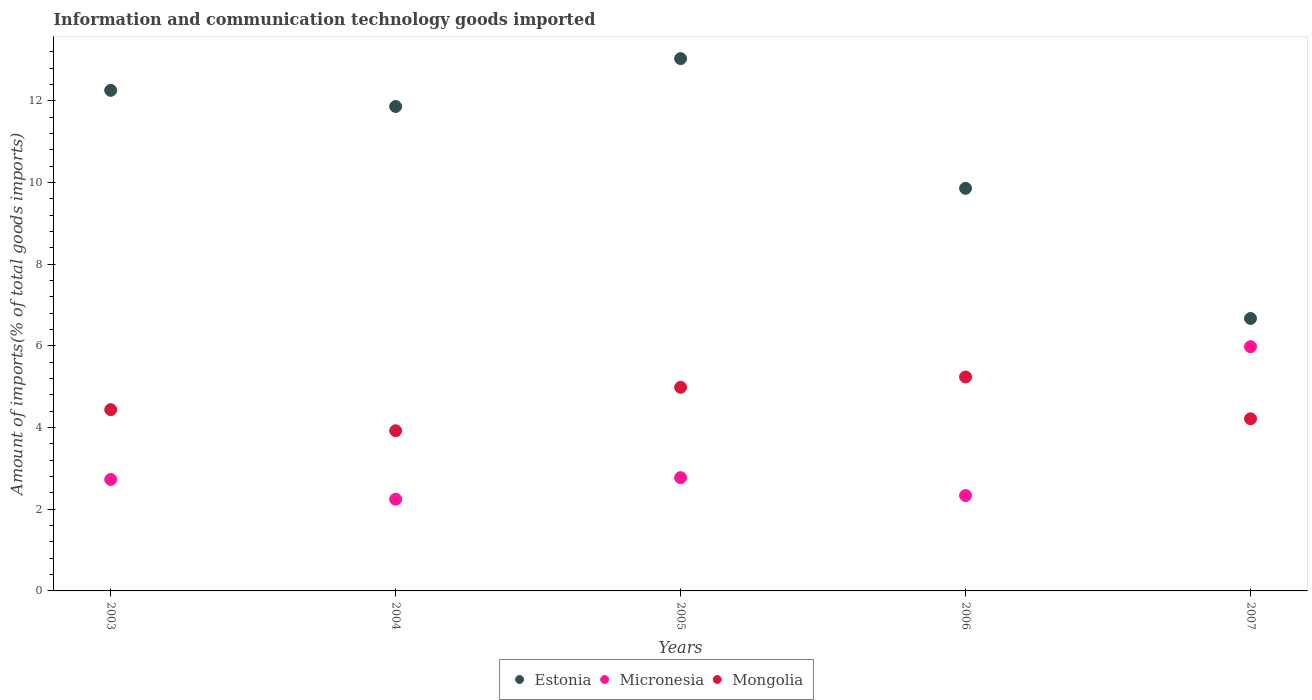Is the number of dotlines equal to the number of legend labels?
Give a very brief answer. Yes. What is the amount of goods imported in Mongolia in 2007?
Keep it short and to the point. 4.22. Across all years, what is the maximum amount of goods imported in Mongolia?
Ensure brevity in your answer.  5.24. Across all years, what is the minimum amount of goods imported in Estonia?
Your answer should be compact. 6.67. In which year was the amount of goods imported in Mongolia maximum?
Ensure brevity in your answer.  2006. What is the total amount of goods imported in Mongolia in the graph?
Ensure brevity in your answer.  22.8. What is the difference between the amount of goods imported in Mongolia in 2004 and that in 2005?
Provide a succinct answer. -1.06. What is the difference between the amount of goods imported in Mongolia in 2006 and the amount of goods imported in Estonia in 2007?
Offer a very short reply. -1.43. What is the average amount of goods imported in Estonia per year?
Make the answer very short. 10.74. In the year 2007, what is the difference between the amount of goods imported in Estonia and amount of goods imported in Micronesia?
Your answer should be compact. 0.69. What is the ratio of the amount of goods imported in Micronesia in 2003 to that in 2007?
Ensure brevity in your answer.  0.46. Is the amount of goods imported in Estonia in 2005 less than that in 2007?
Make the answer very short. No. What is the difference between the highest and the second highest amount of goods imported in Estonia?
Make the answer very short. 0.78. What is the difference between the highest and the lowest amount of goods imported in Micronesia?
Give a very brief answer. 3.73. In how many years, is the amount of goods imported in Mongolia greater than the average amount of goods imported in Mongolia taken over all years?
Give a very brief answer. 2. Is the sum of the amount of goods imported in Estonia in 2003 and 2006 greater than the maximum amount of goods imported in Mongolia across all years?
Give a very brief answer. Yes. What is the difference between two consecutive major ticks on the Y-axis?
Your response must be concise. 2. Does the graph contain grids?
Keep it short and to the point. No. Where does the legend appear in the graph?
Your response must be concise. Bottom center. How are the legend labels stacked?
Keep it short and to the point. Horizontal. What is the title of the graph?
Keep it short and to the point. Information and communication technology goods imported. What is the label or title of the Y-axis?
Provide a succinct answer. Amount of imports(% of total goods imports). What is the Amount of imports(% of total goods imports) in Estonia in 2003?
Your response must be concise. 12.26. What is the Amount of imports(% of total goods imports) of Micronesia in 2003?
Provide a short and direct response. 2.73. What is the Amount of imports(% of total goods imports) of Mongolia in 2003?
Your answer should be very brief. 4.44. What is the Amount of imports(% of total goods imports) of Estonia in 2004?
Offer a very short reply. 11.86. What is the Amount of imports(% of total goods imports) of Micronesia in 2004?
Your response must be concise. 2.25. What is the Amount of imports(% of total goods imports) of Mongolia in 2004?
Offer a very short reply. 3.92. What is the Amount of imports(% of total goods imports) in Estonia in 2005?
Your answer should be compact. 13.04. What is the Amount of imports(% of total goods imports) in Micronesia in 2005?
Offer a terse response. 2.77. What is the Amount of imports(% of total goods imports) in Mongolia in 2005?
Provide a succinct answer. 4.99. What is the Amount of imports(% of total goods imports) of Estonia in 2006?
Keep it short and to the point. 9.86. What is the Amount of imports(% of total goods imports) in Micronesia in 2006?
Your response must be concise. 2.34. What is the Amount of imports(% of total goods imports) in Mongolia in 2006?
Provide a short and direct response. 5.24. What is the Amount of imports(% of total goods imports) in Estonia in 2007?
Provide a short and direct response. 6.67. What is the Amount of imports(% of total goods imports) of Micronesia in 2007?
Your answer should be compact. 5.98. What is the Amount of imports(% of total goods imports) in Mongolia in 2007?
Ensure brevity in your answer.  4.22. Across all years, what is the maximum Amount of imports(% of total goods imports) of Estonia?
Your answer should be compact. 13.04. Across all years, what is the maximum Amount of imports(% of total goods imports) in Micronesia?
Keep it short and to the point. 5.98. Across all years, what is the maximum Amount of imports(% of total goods imports) of Mongolia?
Your answer should be very brief. 5.24. Across all years, what is the minimum Amount of imports(% of total goods imports) of Estonia?
Offer a terse response. 6.67. Across all years, what is the minimum Amount of imports(% of total goods imports) of Micronesia?
Your answer should be very brief. 2.25. Across all years, what is the minimum Amount of imports(% of total goods imports) of Mongolia?
Provide a short and direct response. 3.92. What is the total Amount of imports(% of total goods imports) in Estonia in the graph?
Your answer should be compact. 53.69. What is the total Amount of imports(% of total goods imports) of Micronesia in the graph?
Your answer should be very brief. 16.06. What is the total Amount of imports(% of total goods imports) of Mongolia in the graph?
Offer a very short reply. 22.8. What is the difference between the Amount of imports(% of total goods imports) of Estonia in 2003 and that in 2004?
Provide a short and direct response. 0.4. What is the difference between the Amount of imports(% of total goods imports) of Micronesia in 2003 and that in 2004?
Your response must be concise. 0.48. What is the difference between the Amount of imports(% of total goods imports) of Mongolia in 2003 and that in 2004?
Provide a succinct answer. 0.52. What is the difference between the Amount of imports(% of total goods imports) of Estonia in 2003 and that in 2005?
Your answer should be compact. -0.78. What is the difference between the Amount of imports(% of total goods imports) of Micronesia in 2003 and that in 2005?
Your response must be concise. -0.04. What is the difference between the Amount of imports(% of total goods imports) of Mongolia in 2003 and that in 2005?
Your answer should be very brief. -0.55. What is the difference between the Amount of imports(% of total goods imports) of Estonia in 2003 and that in 2006?
Provide a short and direct response. 2.4. What is the difference between the Amount of imports(% of total goods imports) in Micronesia in 2003 and that in 2006?
Offer a very short reply. 0.39. What is the difference between the Amount of imports(% of total goods imports) of Mongolia in 2003 and that in 2006?
Offer a terse response. -0.8. What is the difference between the Amount of imports(% of total goods imports) in Estonia in 2003 and that in 2007?
Keep it short and to the point. 5.59. What is the difference between the Amount of imports(% of total goods imports) of Micronesia in 2003 and that in 2007?
Your answer should be compact. -3.25. What is the difference between the Amount of imports(% of total goods imports) of Mongolia in 2003 and that in 2007?
Make the answer very short. 0.22. What is the difference between the Amount of imports(% of total goods imports) of Estonia in 2004 and that in 2005?
Provide a short and direct response. -1.17. What is the difference between the Amount of imports(% of total goods imports) in Micronesia in 2004 and that in 2005?
Provide a succinct answer. -0.53. What is the difference between the Amount of imports(% of total goods imports) in Mongolia in 2004 and that in 2005?
Offer a terse response. -1.06. What is the difference between the Amount of imports(% of total goods imports) in Estonia in 2004 and that in 2006?
Make the answer very short. 2. What is the difference between the Amount of imports(% of total goods imports) in Micronesia in 2004 and that in 2006?
Your answer should be compact. -0.09. What is the difference between the Amount of imports(% of total goods imports) in Mongolia in 2004 and that in 2006?
Keep it short and to the point. -1.32. What is the difference between the Amount of imports(% of total goods imports) of Estonia in 2004 and that in 2007?
Give a very brief answer. 5.19. What is the difference between the Amount of imports(% of total goods imports) in Micronesia in 2004 and that in 2007?
Offer a terse response. -3.73. What is the difference between the Amount of imports(% of total goods imports) of Mongolia in 2004 and that in 2007?
Ensure brevity in your answer.  -0.29. What is the difference between the Amount of imports(% of total goods imports) of Estonia in 2005 and that in 2006?
Keep it short and to the point. 3.18. What is the difference between the Amount of imports(% of total goods imports) of Micronesia in 2005 and that in 2006?
Your answer should be compact. 0.44. What is the difference between the Amount of imports(% of total goods imports) in Mongolia in 2005 and that in 2006?
Give a very brief answer. -0.25. What is the difference between the Amount of imports(% of total goods imports) of Estonia in 2005 and that in 2007?
Keep it short and to the point. 6.36. What is the difference between the Amount of imports(% of total goods imports) of Micronesia in 2005 and that in 2007?
Your response must be concise. -3.21. What is the difference between the Amount of imports(% of total goods imports) in Mongolia in 2005 and that in 2007?
Give a very brief answer. 0.77. What is the difference between the Amount of imports(% of total goods imports) of Estonia in 2006 and that in 2007?
Your response must be concise. 3.19. What is the difference between the Amount of imports(% of total goods imports) in Micronesia in 2006 and that in 2007?
Ensure brevity in your answer.  -3.65. What is the difference between the Amount of imports(% of total goods imports) of Mongolia in 2006 and that in 2007?
Offer a very short reply. 1.02. What is the difference between the Amount of imports(% of total goods imports) of Estonia in 2003 and the Amount of imports(% of total goods imports) of Micronesia in 2004?
Your answer should be very brief. 10.01. What is the difference between the Amount of imports(% of total goods imports) in Estonia in 2003 and the Amount of imports(% of total goods imports) in Mongolia in 2004?
Ensure brevity in your answer.  8.34. What is the difference between the Amount of imports(% of total goods imports) of Micronesia in 2003 and the Amount of imports(% of total goods imports) of Mongolia in 2004?
Give a very brief answer. -1.19. What is the difference between the Amount of imports(% of total goods imports) in Estonia in 2003 and the Amount of imports(% of total goods imports) in Micronesia in 2005?
Your answer should be very brief. 9.49. What is the difference between the Amount of imports(% of total goods imports) of Estonia in 2003 and the Amount of imports(% of total goods imports) of Mongolia in 2005?
Provide a succinct answer. 7.27. What is the difference between the Amount of imports(% of total goods imports) in Micronesia in 2003 and the Amount of imports(% of total goods imports) in Mongolia in 2005?
Make the answer very short. -2.26. What is the difference between the Amount of imports(% of total goods imports) in Estonia in 2003 and the Amount of imports(% of total goods imports) in Micronesia in 2006?
Make the answer very short. 9.92. What is the difference between the Amount of imports(% of total goods imports) of Estonia in 2003 and the Amount of imports(% of total goods imports) of Mongolia in 2006?
Your response must be concise. 7.02. What is the difference between the Amount of imports(% of total goods imports) in Micronesia in 2003 and the Amount of imports(% of total goods imports) in Mongolia in 2006?
Your response must be concise. -2.51. What is the difference between the Amount of imports(% of total goods imports) of Estonia in 2003 and the Amount of imports(% of total goods imports) of Micronesia in 2007?
Your answer should be compact. 6.28. What is the difference between the Amount of imports(% of total goods imports) of Estonia in 2003 and the Amount of imports(% of total goods imports) of Mongolia in 2007?
Keep it short and to the point. 8.04. What is the difference between the Amount of imports(% of total goods imports) in Micronesia in 2003 and the Amount of imports(% of total goods imports) in Mongolia in 2007?
Your answer should be very brief. -1.49. What is the difference between the Amount of imports(% of total goods imports) of Estonia in 2004 and the Amount of imports(% of total goods imports) of Micronesia in 2005?
Your response must be concise. 9.09. What is the difference between the Amount of imports(% of total goods imports) in Estonia in 2004 and the Amount of imports(% of total goods imports) in Mongolia in 2005?
Your answer should be very brief. 6.88. What is the difference between the Amount of imports(% of total goods imports) of Micronesia in 2004 and the Amount of imports(% of total goods imports) of Mongolia in 2005?
Make the answer very short. -2.74. What is the difference between the Amount of imports(% of total goods imports) in Estonia in 2004 and the Amount of imports(% of total goods imports) in Micronesia in 2006?
Give a very brief answer. 9.53. What is the difference between the Amount of imports(% of total goods imports) in Estonia in 2004 and the Amount of imports(% of total goods imports) in Mongolia in 2006?
Your answer should be very brief. 6.62. What is the difference between the Amount of imports(% of total goods imports) of Micronesia in 2004 and the Amount of imports(% of total goods imports) of Mongolia in 2006?
Keep it short and to the point. -2.99. What is the difference between the Amount of imports(% of total goods imports) in Estonia in 2004 and the Amount of imports(% of total goods imports) in Micronesia in 2007?
Provide a short and direct response. 5.88. What is the difference between the Amount of imports(% of total goods imports) in Estonia in 2004 and the Amount of imports(% of total goods imports) in Mongolia in 2007?
Keep it short and to the point. 7.65. What is the difference between the Amount of imports(% of total goods imports) of Micronesia in 2004 and the Amount of imports(% of total goods imports) of Mongolia in 2007?
Keep it short and to the point. -1.97. What is the difference between the Amount of imports(% of total goods imports) of Estonia in 2005 and the Amount of imports(% of total goods imports) of Micronesia in 2006?
Make the answer very short. 10.7. What is the difference between the Amount of imports(% of total goods imports) in Estonia in 2005 and the Amount of imports(% of total goods imports) in Mongolia in 2006?
Your answer should be very brief. 7.8. What is the difference between the Amount of imports(% of total goods imports) in Micronesia in 2005 and the Amount of imports(% of total goods imports) in Mongolia in 2006?
Offer a very short reply. -2.47. What is the difference between the Amount of imports(% of total goods imports) of Estonia in 2005 and the Amount of imports(% of total goods imports) of Micronesia in 2007?
Your answer should be very brief. 7.06. What is the difference between the Amount of imports(% of total goods imports) of Estonia in 2005 and the Amount of imports(% of total goods imports) of Mongolia in 2007?
Provide a succinct answer. 8.82. What is the difference between the Amount of imports(% of total goods imports) of Micronesia in 2005 and the Amount of imports(% of total goods imports) of Mongolia in 2007?
Ensure brevity in your answer.  -1.44. What is the difference between the Amount of imports(% of total goods imports) in Estonia in 2006 and the Amount of imports(% of total goods imports) in Micronesia in 2007?
Offer a very short reply. 3.88. What is the difference between the Amount of imports(% of total goods imports) of Estonia in 2006 and the Amount of imports(% of total goods imports) of Mongolia in 2007?
Your response must be concise. 5.64. What is the difference between the Amount of imports(% of total goods imports) of Micronesia in 2006 and the Amount of imports(% of total goods imports) of Mongolia in 2007?
Your response must be concise. -1.88. What is the average Amount of imports(% of total goods imports) in Estonia per year?
Provide a short and direct response. 10.74. What is the average Amount of imports(% of total goods imports) in Micronesia per year?
Offer a very short reply. 3.21. What is the average Amount of imports(% of total goods imports) of Mongolia per year?
Keep it short and to the point. 4.56. In the year 2003, what is the difference between the Amount of imports(% of total goods imports) of Estonia and Amount of imports(% of total goods imports) of Micronesia?
Ensure brevity in your answer.  9.53. In the year 2003, what is the difference between the Amount of imports(% of total goods imports) of Estonia and Amount of imports(% of total goods imports) of Mongolia?
Your response must be concise. 7.82. In the year 2003, what is the difference between the Amount of imports(% of total goods imports) in Micronesia and Amount of imports(% of total goods imports) in Mongolia?
Ensure brevity in your answer.  -1.71. In the year 2004, what is the difference between the Amount of imports(% of total goods imports) in Estonia and Amount of imports(% of total goods imports) in Micronesia?
Offer a terse response. 9.62. In the year 2004, what is the difference between the Amount of imports(% of total goods imports) in Estonia and Amount of imports(% of total goods imports) in Mongolia?
Ensure brevity in your answer.  7.94. In the year 2004, what is the difference between the Amount of imports(% of total goods imports) in Micronesia and Amount of imports(% of total goods imports) in Mongolia?
Ensure brevity in your answer.  -1.68. In the year 2005, what is the difference between the Amount of imports(% of total goods imports) of Estonia and Amount of imports(% of total goods imports) of Micronesia?
Provide a succinct answer. 10.26. In the year 2005, what is the difference between the Amount of imports(% of total goods imports) of Estonia and Amount of imports(% of total goods imports) of Mongolia?
Provide a succinct answer. 8.05. In the year 2005, what is the difference between the Amount of imports(% of total goods imports) of Micronesia and Amount of imports(% of total goods imports) of Mongolia?
Give a very brief answer. -2.21. In the year 2006, what is the difference between the Amount of imports(% of total goods imports) in Estonia and Amount of imports(% of total goods imports) in Micronesia?
Give a very brief answer. 7.52. In the year 2006, what is the difference between the Amount of imports(% of total goods imports) of Estonia and Amount of imports(% of total goods imports) of Mongolia?
Ensure brevity in your answer.  4.62. In the year 2006, what is the difference between the Amount of imports(% of total goods imports) of Micronesia and Amount of imports(% of total goods imports) of Mongolia?
Provide a short and direct response. -2.91. In the year 2007, what is the difference between the Amount of imports(% of total goods imports) in Estonia and Amount of imports(% of total goods imports) in Micronesia?
Offer a very short reply. 0.69. In the year 2007, what is the difference between the Amount of imports(% of total goods imports) in Estonia and Amount of imports(% of total goods imports) in Mongolia?
Offer a terse response. 2.46. In the year 2007, what is the difference between the Amount of imports(% of total goods imports) in Micronesia and Amount of imports(% of total goods imports) in Mongolia?
Provide a succinct answer. 1.77. What is the ratio of the Amount of imports(% of total goods imports) of Micronesia in 2003 to that in 2004?
Offer a terse response. 1.22. What is the ratio of the Amount of imports(% of total goods imports) in Mongolia in 2003 to that in 2004?
Provide a succinct answer. 1.13. What is the ratio of the Amount of imports(% of total goods imports) in Estonia in 2003 to that in 2005?
Offer a very short reply. 0.94. What is the ratio of the Amount of imports(% of total goods imports) of Micronesia in 2003 to that in 2005?
Offer a terse response. 0.98. What is the ratio of the Amount of imports(% of total goods imports) in Mongolia in 2003 to that in 2005?
Give a very brief answer. 0.89. What is the ratio of the Amount of imports(% of total goods imports) of Estonia in 2003 to that in 2006?
Keep it short and to the point. 1.24. What is the ratio of the Amount of imports(% of total goods imports) of Micronesia in 2003 to that in 2006?
Your answer should be compact. 1.17. What is the ratio of the Amount of imports(% of total goods imports) in Mongolia in 2003 to that in 2006?
Your response must be concise. 0.85. What is the ratio of the Amount of imports(% of total goods imports) of Estonia in 2003 to that in 2007?
Your answer should be compact. 1.84. What is the ratio of the Amount of imports(% of total goods imports) in Micronesia in 2003 to that in 2007?
Keep it short and to the point. 0.46. What is the ratio of the Amount of imports(% of total goods imports) in Mongolia in 2003 to that in 2007?
Make the answer very short. 1.05. What is the ratio of the Amount of imports(% of total goods imports) of Estonia in 2004 to that in 2005?
Keep it short and to the point. 0.91. What is the ratio of the Amount of imports(% of total goods imports) in Micronesia in 2004 to that in 2005?
Ensure brevity in your answer.  0.81. What is the ratio of the Amount of imports(% of total goods imports) in Mongolia in 2004 to that in 2005?
Your answer should be very brief. 0.79. What is the ratio of the Amount of imports(% of total goods imports) of Estonia in 2004 to that in 2006?
Your answer should be compact. 1.2. What is the ratio of the Amount of imports(% of total goods imports) of Micronesia in 2004 to that in 2006?
Your answer should be very brief. 0.96. What is the ratio of the Amount of imports(% of total goods imports) in Mongolia in 2004 to that in 2006?
Offer a very short reply. 0.75. What is the ratio of the Amount of imports(% of total goods imports) in Estonia in 2004 to that in 2007?
Offer a very short reply. 1.78. What is the ratio of the Amount of imports(% of total goods imports) of Micronesia in 2004 to that in 2007?
Your answer should be very brief. 0.38. What is the ratio of the Amount of imports(% of total goods imports) of Mongolia in 2004 to that in 2007?
Offer a very short reply. 0.93. What is the ratio of the Amount of imports(% of total goods imports) of Estonia in 2005 to that in 2006?
Provide a short and direct response. 1.32. What is the ratio of the Amount of imports(% of total goods imports) in Micronesia in 2005 to that in 2006?
Offer a terse response. 1.19. What is the ratio of the Amount of imports(% of total goods imports) in Mongolia in 2005 to that in 2006?
Your response must be concise. 0.95. What is the ratio of the Amount of imports(% of total goods imports) in Estonia in 2005 to that in 2007?
Give a very brief answer. 1.95. What is the ratio of the Amount of imports(% of total goods imports) of Micronesia in 2005 to that in 2007?
Make the answer very short. 0.46. What is the ratio of the Amount of imports(% of total goods imports) of Mongolia in 2005 to that in 2007?
Your answer should be compact. 1.18. What is the ratio of the Amount of imports(% of total goods imports) of Estonia in 2006 to that in 2007?
Provide a short and direct response. 1.48. What is the ratio of the Amount of imports(% of total goods imports) in Micronesia in 2006 to that in 2007?
Offer a terse response. 0.39. What is the ratio of the Amount of imports(% of total goods imports) in Mongolia in 2006 to that in 2007?
Your answer should be compact. 1.24. What is the difference between the highest and the second highest Amount of imports(% of total goods imports) of Estonia?
Provide a short and direct response. 0.78. What is the difference between the highest and the second highest Amount of imports(% of total goods imports) of Micronesia?
Your answer should be very brief. 3.21. What is the difference between the highest and the second highest Amount of imports(% of total goods imports) of Mongolia?
Your answer should be very brief. 0.25. What is the difference between the highest and the lowest Amount of imports(% of total goods imports) of Estonia?
Provide a short and direct response. 6.36. What is the difference between the highest and the lowest Amount of imports(% of total goods imports) in Micronesia?
Give a very brief answer. 3.73. What is the difference between the highest and the lowest Amount of imports(% of total goods imports) of Mongolia?
Your answer should be compact. 1.32. 